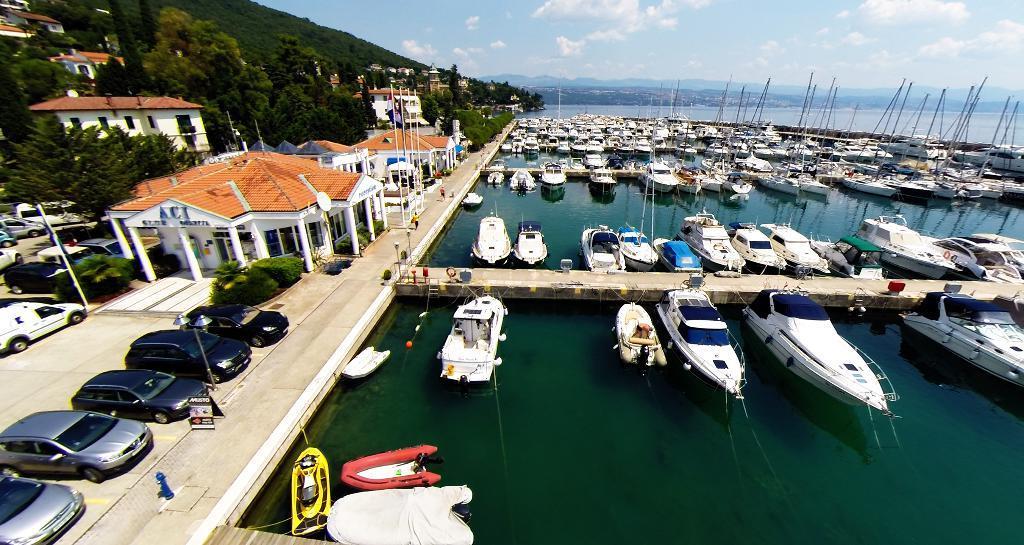How would you summarize this image in a sentence or two? In this picture I can see few boats in the water and I can see couple of wooden bridges and I can see cars parked and few trees and buildings and I can see few flags and couple of them walking and I can see hills and a blue cloudy sky. 